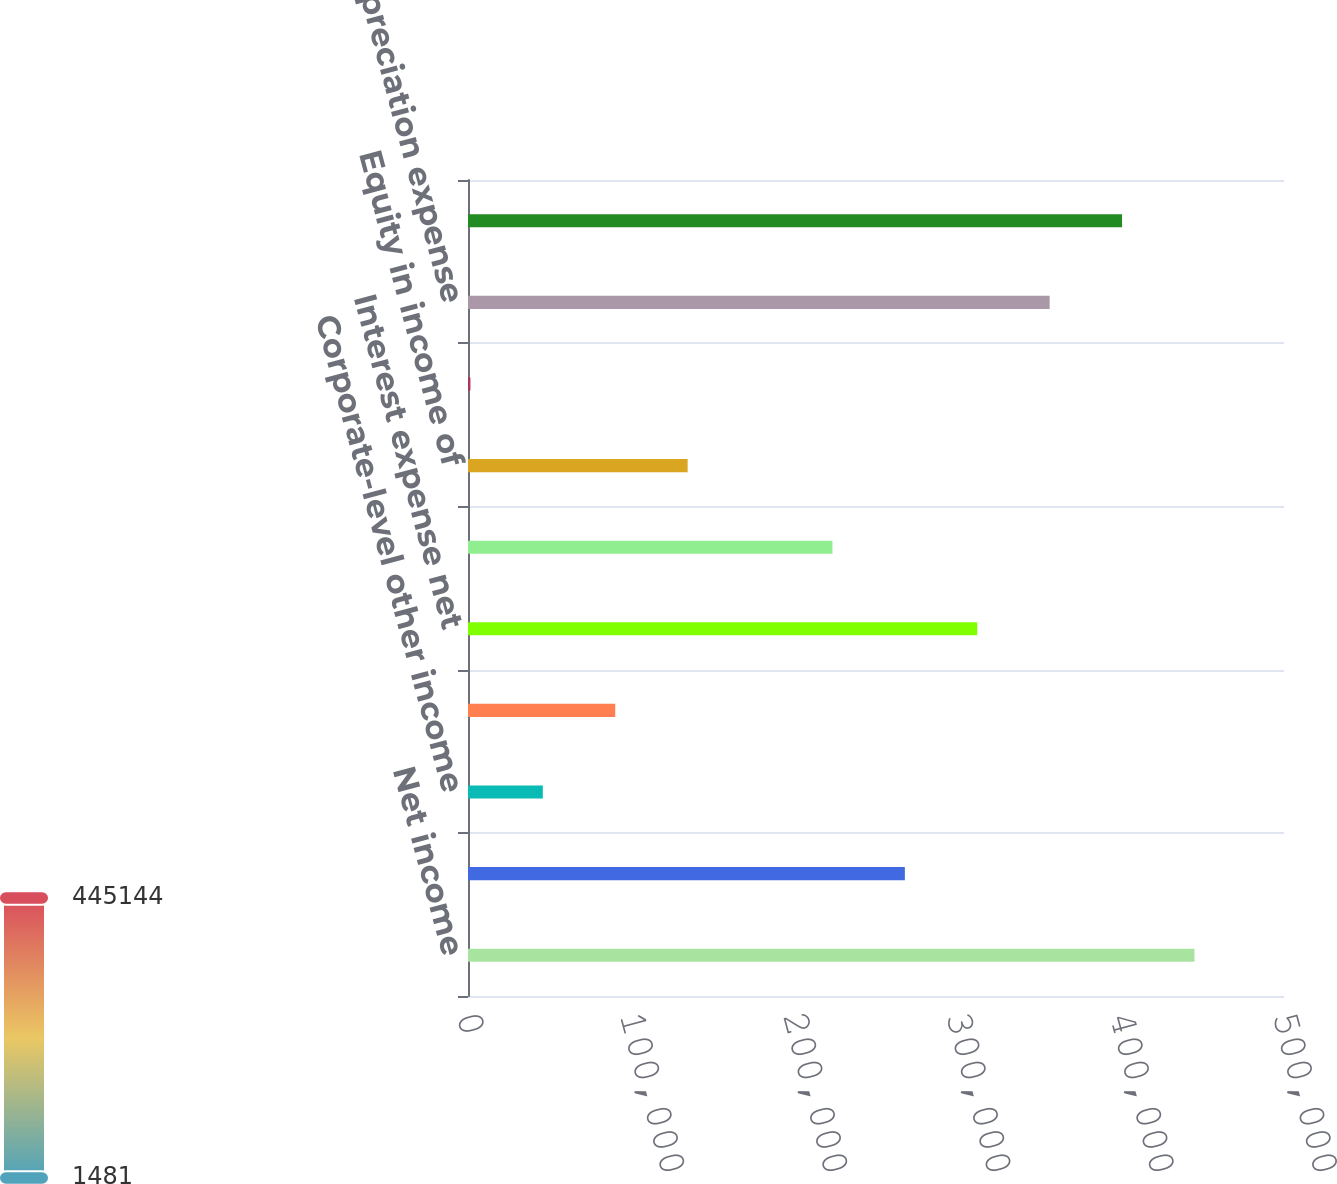Convert chart to OTSL. <chart><loc_0><loc_0><loc_500><loc_500><bar_chart><fcel>Net income<fcel>Corporate-level property<fcel>Corporate-level other income<fcel>Investments and investment<fcel>Interest expense net<fcel>General and administrative<fcel>Equity in income of<fcel>Minority interest in<fcel>Depreciation expense<fcel>Gain on sale of real estate<nl><fcel>445144<fcel>267679<fcel>45847.3<fcel>90213.6<fcel>312045<fcel>223312<fcel>134580<fcel>1481<fcel>356411<fcel>400778<nl></chart> 